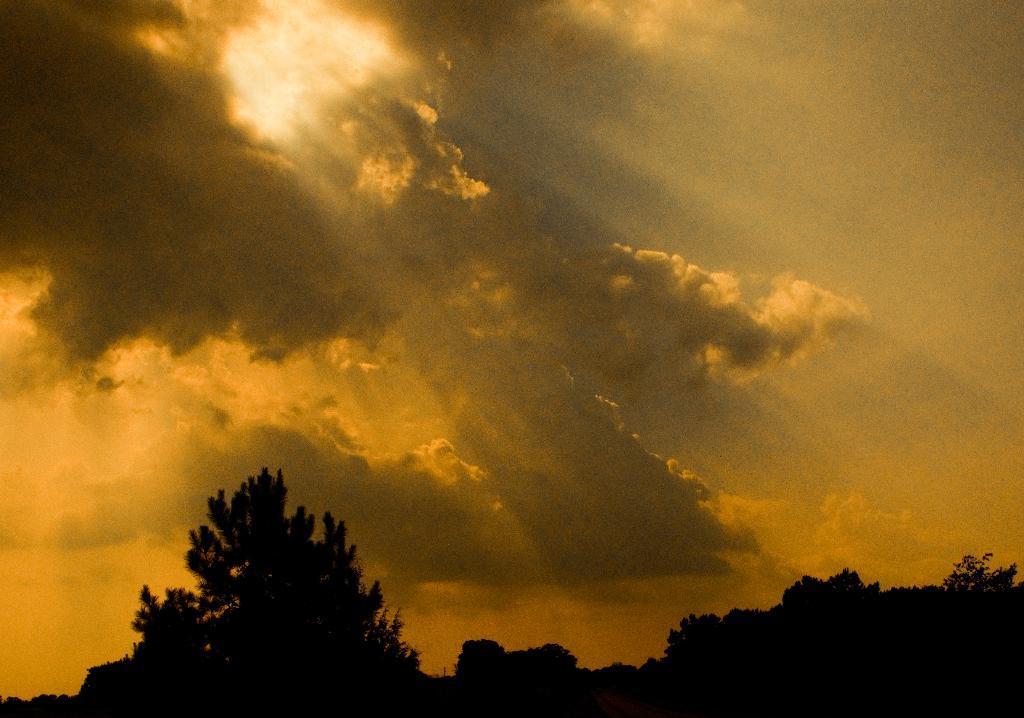Could you give a brief overview of what you see in this image? In this picture we can observe trees. In the background there is a sky and clouds. The sky is in yellow color. 